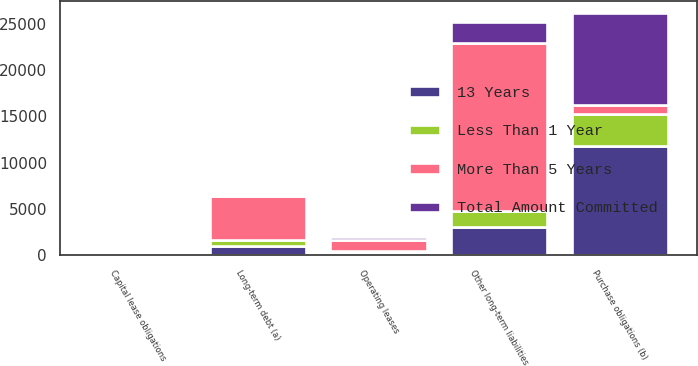Convert chart to OTSL. <chart><loc_0><loc_0><loc_500><loc_500><stacked_bar_chart><ecel><fcel>Long-term debt (a)<fcel>Capital lease obligations<fcel>Operating leases<fcel>Purchase obligations (b)<fcel>Other long-term liabilities<nl><fcel>More Than 5 Years<fcel>4791<fcel>30<fcel>1187<fcel>991<fcel>18169<nl><fcel>13 Years<fcel>991<fcel>2<fcel>241<fcel>11783<fcel>3004<nl><fcel>Total Amount Committed<fcel>162<fcel>5<fcel>339<fcel>9938<fcel>2287<nl><fcel>Less Than 1 Year<fcel>661<fcel>4<fcel>164<fcel>3443<fcel>1783<nl></chart> 